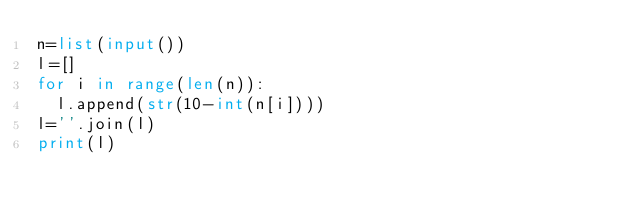<code> <loc_0><loc_0><loc_500><loc_500><_Python_>n=list(input())
l=[]
for i in range(len(n)):
  l.append(str(10-int(n[i])))
l=''.join(l)
print(l)</code> 